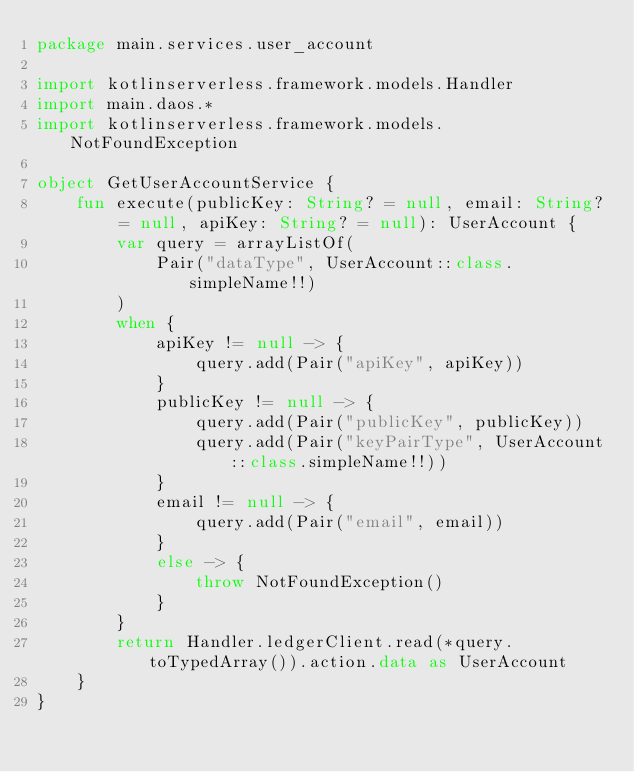Convert code to text. <code><loc_0><loc_0><loc_500><loc_500><_Kotlin_>package main.services.user_account

import kotlinserverless.framework.models.Handler
import main.daos.*
import kotlinserverless.framework.models.NotFoundException

object GetUserAccountService {
    fun execute(publicKey: String? = null, email: String? = null, apiKey: String? = null): UserAccount {
        var query = arrayListOf(
            Pair("dataType", UserAccount::class.simpleName!!)
        )
        when {
            apiKey != null -> {
                query.add(Pair("apiKey", apiKey))
            }
            publicKey != null -> {
                query.add(Pair("publicKey", publicKey))
                query.add(Pair("keyPairType", UserAccount::class.simpleName!!))
            }
            email != null -> {
                query.add(Pair("email", email))
            }
            else -> {
                throw NotFoundException()
            }
        }
        return Handler.ledgerClient.read(*query.toTypedArray()).action.data as UserAccount
    }
}</code> 